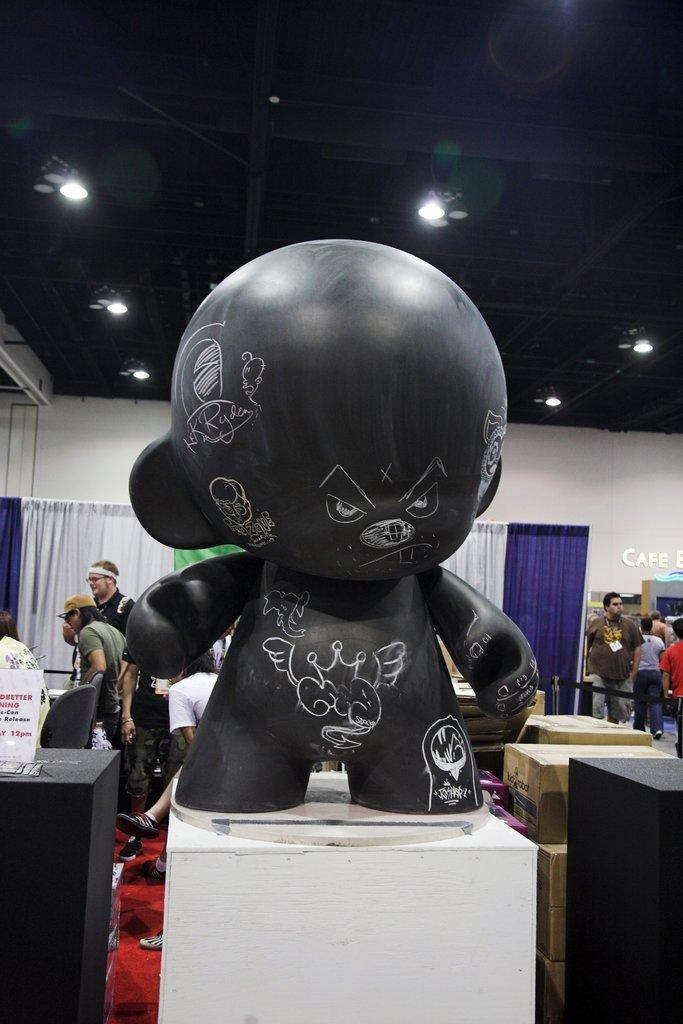In one or two sentences, can you explain what this image depicts? In the center of the image there is toy. In the background of the image there are people. At the top of the image there is ceiling with lights. In the background of the image there is wall. 